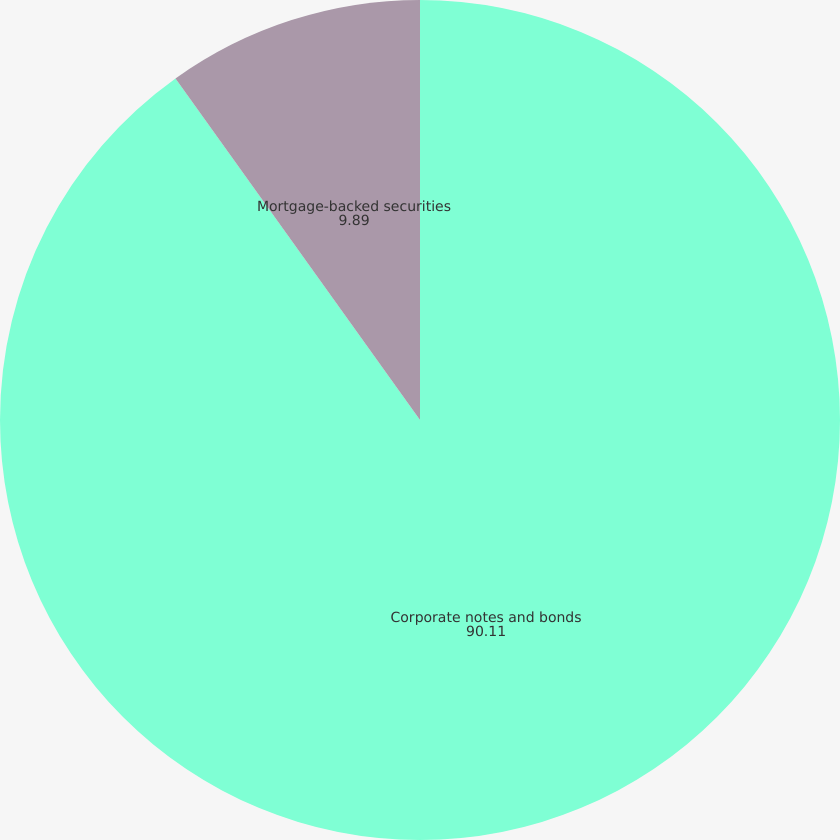Convert chart. <chart><loc_0><loc_0><loc_500><loc_500><pie_chart><fcel>Corporate notes and bonds<fcel>Mortgage-backed securities<nl><fcel>90.11%<fcel>9.89%<nl></chart> 